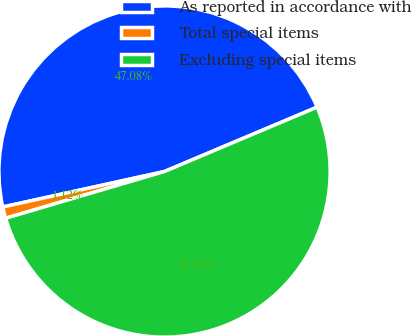Convert chart. <chart><loc_0><loc_0><loc_500><loc_500><pie_chart><fcel>As reported in accordance with<fcel>Total special items<fcel>Excluding special items<nl><fcel>47.08%<fcel>1.12%<fcel>51.79%<nl></chart> 